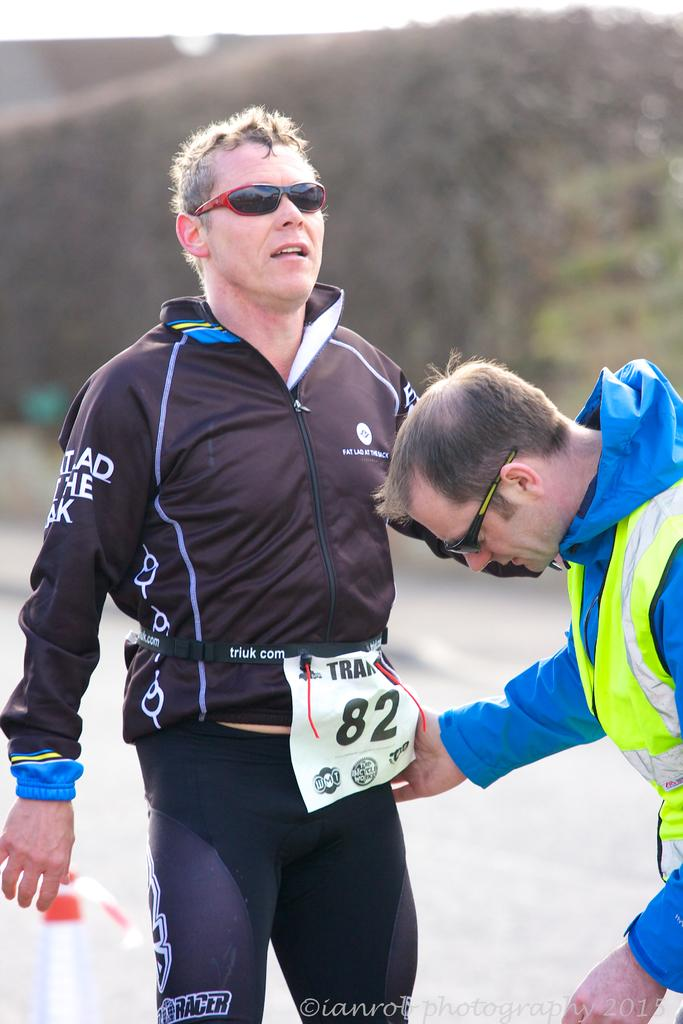<image>
Write a terse but informative summary of the picture. Number 82 in a running race stretches outside and seems to be in pain. 